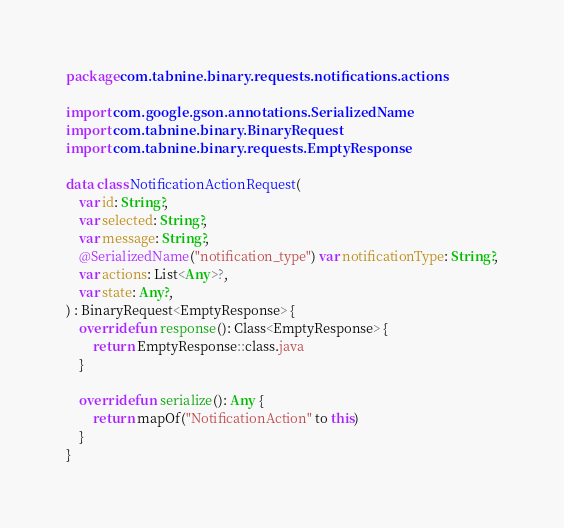<code> <loc_0><loc_0><loc_500><loc_500><_Kotlin_>package com.tabnine.binary.requests.notifications.actions

import com.google.gson.annotations.SerializedName
import com.tabnine.binary.BinaryRequest
import com.tabnine.binary.requests.EmptyResponse

data class NotificationActionRequest(
    var id: String?,
    var selected: String?,
    var message: String?,
    @SerializedName("notification_type") var notificationType: String?,
    var actions: List<Any>?,
    var state: Any?,
) : BinaryRequest<EmptyResponse> {
    override fun response(): Class<EmptyResponse> {
        return EmptyResponse::class.java
    }

    override fun serialize(): Any {
        return mapOf("NotificationAction" to this)
    }
}
</code> 